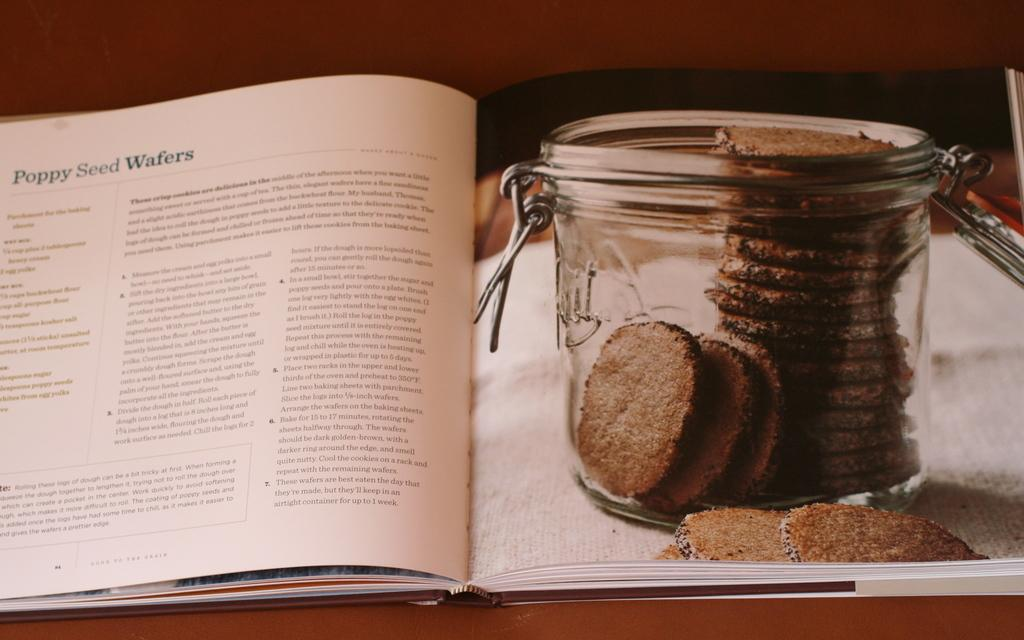<image>
Summarize the visual content of the image. a book about Poppy Seed wafers with wafers next to it 